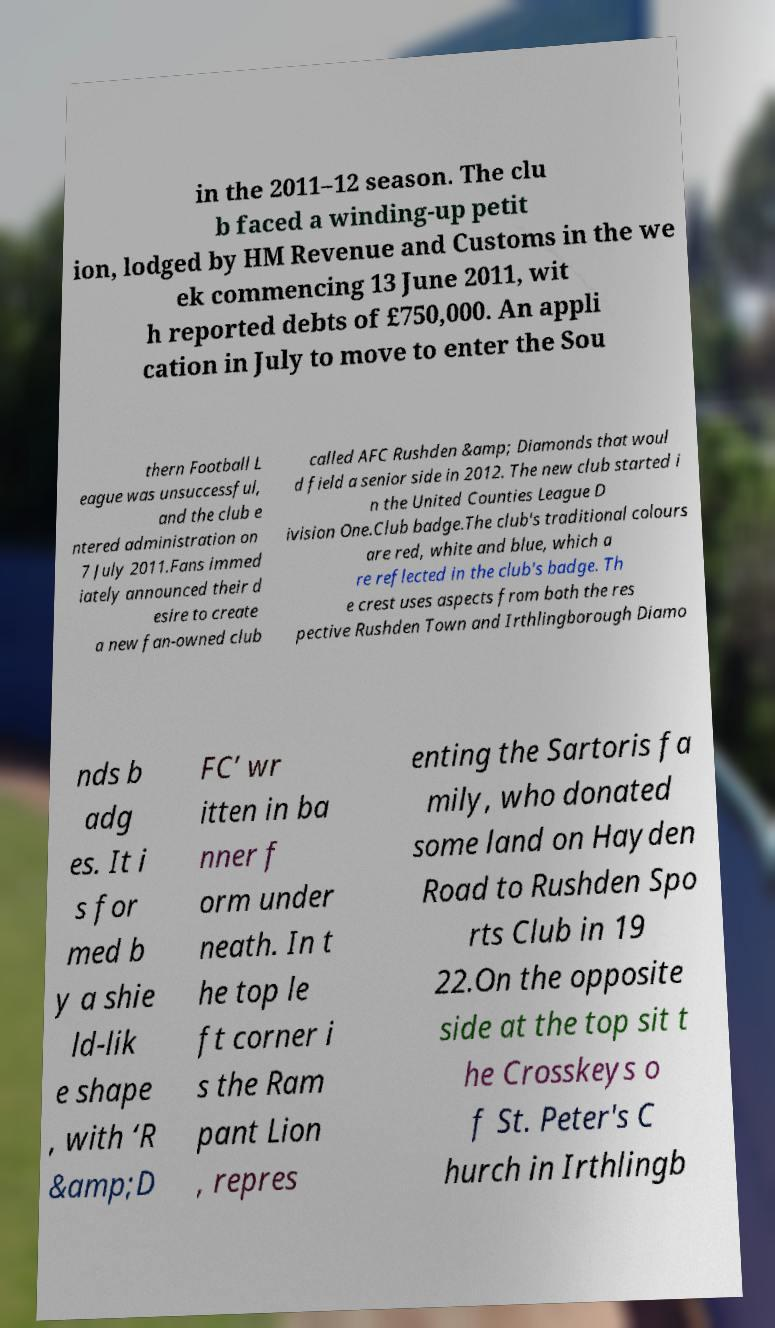Can you read and provide the text displayed in the image?This photo seems to have some interesting text. Can you extract and type it out for me? in the 2011–12 season. The clu b faced a winding-up petit ion, lodged by HM Revenue and Customs in the we ek commencing 13 June 2011, wit h reported debts of £750,000. An appli cation in July to move to enter the Sou thern Football L eague was unsuccessful, and the club e ntered administration on 7 July 2011.Fans immed iately announced their d esire to create a new fan-owned club called AFC Rushden &amp; Diamonds that woul d field a senior side in 2012. The new club started i n the United Counties League D ivision One.Club badge.The club's traditional colours are red, white and blue, which a re reflected in the club's badge. Th e crest uses aspects from both the res pective Rushden Town and Irthlingborough Diamo nds b adg es. It i s for med b y a shie ld-lik e shape , with ‘R &amp;D FC’ wr itten in ba nner f orm under neath. In t he top le ft corner i s the Ram pant Lion , repres enting the Sartoris fa mily, who donated some land on Hayden Road to Rushden Spo rts Club in 19 22.On the opposite side at the top sit t he Crosskeys o f St. Peter's C hurch in Irthlingb 